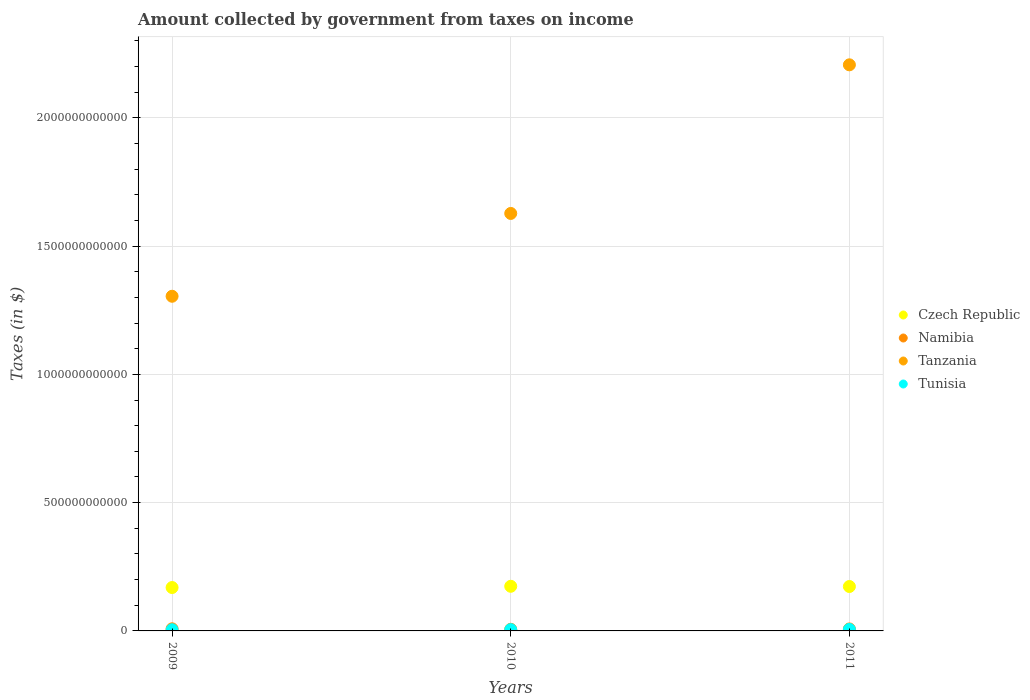What is the amount collected by government from taxes on income in Tunisia in 2010?
Offer a terse response. 5.03e+09. Across all years, what is the maximum amount collected by government from taxes on income in Tanzania?
Give a very brief answer. 2.21e+12. Across all years, what is the minimum amount collected by government from taxes on income in Tunisia?
Offer a very short reply. 4.65e+09. What is the total amount collected by government from taxes on income in Namibia in the graph?
Your answer should be very brief. 2.22e+1. What is the difference between the amount collected by government from taxes on income in Tanzania in 2009 and that in 2011?
Your answer should be compact. -9.02e+11. What is the difference between the amount collected by government from taxes on income in Tunisia in 2009 and the amount collected by government from taxes on income in Czech Republic in 2010?
Offer a terse response. -1.69e+11. What is the average amount collected by government from taxes on income in Czech Republic per year?
Ensure brevity in your answer.  1.72e+11. In the year 2010, what is the difference between the amount collected by government from taxes on income in Tanzania and amount collected by government from taxes on income in Tunisia?
Keep it short and to the point. 1.62e+12. In how many years, is the amount collected by government from taxes on income in Tanzania greater than 500000000000 $?
Your answer should be compact. 3. What is the ratio of the amount collected by government from taxes on income in Tanzania in 2010 to that in 2011?
Offer a terse response. 0.74. Is the amount collected by government from taxes on income in Tanzania in 2010 less than that in 2011?
Your answer should be compact. Yes. What is the difference between the highest and the second highest amount collected by government from taxes on income in Namibia?
Provide a succinct answer. 4.52e+08. What is the difference between the highest and the lowest amount collected by government from taxes on income in Tanzania?
Ensure brevity in your answer.  9.02e+11. In how many years, is the amount collected by government from taxes on income in Namibia greater than the average amount collected by government from taxes on income in Namibia taken over all years?
Your answer should be very brief. 2. Is the sum of the amount collected by government from taxes on income in Tanzania in 2009 and 2010 greater than the maximum amount collected by government from taxes on income in Namibia across all years?
Your response must be concise. Yes. Is it the case that in every year, the sum of the amount collected by government from taxes on income in Tanzania and amount collected by government from taxes on income in Namibia  is greater than the sum of amount collected by government from taxes on income in Czech Republic and amount collected by government from taxes on income in Tunisia?
Make the answer very short. Yes. Is it the case that in every year, the sum of the amount collected by government from taxes on income in Czech Republic and amount collected by government from taxes on income in Tanzania  is greater than the amount collected by government from taxes on income in Namibia?
Keep it short and to the point. Yes. How many years are there in the graph?
Provide a short and direct response. 3. What is the difference between two consecutive major ticks on the Y-axis?
Give a very brief answer. 5.00e+11. Are the values on the major ticks of Y-axis written in scientific E-notation?
Ensure brevity in your answer.  No. Does the graph contain any zero values?
Provide a succinct answer. No. Does the graph contain grids?
Offer a terse response. Yes. How many legend labels are there?
Make the answer very short. 4. How are the legend labels stacked?
Ensure brevity in your answer.  Vertical. What is the title of the graph?
Your answer should be compact. Amount collected by government from taxes on income. What is the label or title of the Y-axis?
Your response must be concise. Taxes (in $). What is the Taxes (in $) of Czech Republic in 2009?
Your answer should be very brief. 1.69e+11. What is the Taxes (in $) in Namibia in 2009?
Give a very brief answer. 8.14e+09. What is the Taxes (in $) of Tanzania in 2009?
Give a very brief answer. 1.30e+12. What is the Taxes (in $) in Tunisia in 2009?
Your answer should be very brief. 4.65e+09. What is the Taxes (in $) of Czech Republic in 2010?
Offer a very short reply. 1.74e+11. What is the Taxes (in $) of Namibia in 2010?
Provide a short and direct response. 6.33e+09. What is the Taxes (in $) of Tanzania in 2010?
Your answer should be very brief. 1.63e+12. What is the Taxes (in $) in Tunisia in 2010?
Your answer should be compact. 5.03e+09. What is the Taxes (in $) in Czech Republic in 2011?
Provide a succinct answer. 1.73e+11. What is the Taxes (in $) of Namibia in 2011?
Ensure brevity in your answer.  7.68e+09. What is the Taxes (in $) in Tanzania in 2011?
Offer a terse response. 2.21e+12. What is the Taxes (in $) in Tunisia in 2011?
Make the answer very short. 5.94e+09. Across all years, what is the maximum Taxes (in $) in Czech Republic?
Ensure brevity in your answer.  1.74e+11. Across all years, what is the maximum Taxes (in $) of Namibia?
Offer a terse response. 8.14e+09. Across all years, what is the maximum Taxes (in $) in Tanzania?
Keep it short and to the point. 2.21e+12. Across all years, what is the maximum Taxes (in $) in Tunisia?
Your response must be concise. 5.94e+09. Across all years, what is the minimum Taxes (in $) in Czech Republic?
Give a very brief answer. 1.69e+11. Across all years, what is the minimum Taxes (in $) in Namibia?
Your response must be concise. 6.33e+09. Across all years, what is the minimum Taxes (in $) in Tanzania?
Keep it short and to the point. 1.30e+12. Across all years, what is the minimum Taxes (in $) of Tunisia?
Give a very brief answer. 4.65e+09. What is the total Taxes (in $) of Czech Republic in the graph?
Provide a succinct answer. 5.16e+11. What is the total Taxes (in $) in Namibia in the graph?
Your answer should be very brief. 2.22e+1. What is the total Taxes (in $) in Tanzania in the graph?
Make the answer very short. 5.14e+12. What is the total Taxes (in $) of Tunisia in the graph?
Your response must be concise. 1.56e+1. What is the difference between the Taxes (in $) in Czech Republic in 2009 and that in 2010?
Offer a terse response. -4.83e+09. What is the difference between the Taxes (in $) in Namibia in 2009 and that in 2010?
Offer a terse response. 1.81e+09. What is the difference between the Taxes (in $) in Tanzania in 2009 and that in 2010?
Your answer should be compact. -3.23e+11. What is the difference between the Taxes (in $) of Tunisia in 2009 and that in 2010?
Provide a short and direct response. -3.87e+08. What is the difference between the Taxes (in $) in Czech Republic in 2009 and that in 2011?
Your response must be concise. -3.98e+09. What is the difference between the Taxes (in $) of Namibia in 2009 and that in 2011?
Ensure brevity in your answer.  4.52e+08. What is the difference between the Taxes (in $) of Tanzania in 2009 and that in 2011?
Give a very brief answer. -9.02e+11. What is the difference between the Taxes (in $) in Tunisia in 2009 and that in 2011?
Offer a very short reply. -1.29e+09. What is the difference between the Taxes (in $) of Czech Republic in 2010 and that in 2011?
Provide a succinct answer. 8.53e+08. What is the difference between the Taxes (in $) in Namibia in 2010 and that in 2011?
Give a very brief answer. -1.36e+09. What is the difference between the Taxes (in $) of Tanzania in 2010 and that in 2011?
Keep it short and to the point. -5.79e+11. What is the difference between the Taxes (in $) of Tunisia in 2010 and that in 2011?
Keep it short and to the point. -9.03e+08. What is the difference between the Taxes (in $) in Czech Republic in 2009 and the Taxes (in $) in Namibia in 2010?
Offer a very short reply. 1.63e+11. What is the difference between the Taxes (in $) in Czech Republic in 2009 and the Taxes (in $) in Tanzania in 2010?
Your response must be concise. -1.46e+12. What is the difference between the Taxes (in $) in Czech Republic in 2009 and the Taxes (in $) in Tunisia in 2010?
Your answer should be compact. 1.64e+11. What is the difference between the Taxes (in $) of Namibia in 2009 and the Taxes (in $) of Tanzania in 2010?
Offer a very short reply. -1.62e+12. What is the difference between the Taxes (in $) of Namibia in 2009 and the Taxes (in $) of Tunisia in 2010?
Your response must be concise. 3.10e+09. What is the difference between the Taxes (in $) of Tanzania in 2009 and the Taxes (in $) of Tunisia in 2010?
Give a very brief answer. 1.30e+12. What is the difference between the Taxes (in $) of Czech Republic in 2009 and the Taxes (in $) of Namibia in 2011?
Provide a succinct answer. 1.61e+11. What is the difference between the Taxes (in $) in Czech Republic in 2009 and the Taxes (in $) in Tanzania in 2011?
Keep it short and to the point. -2.04e+12. What is the difference between the Taxes (in $) in Czech Republic in 2009 and the Taxes (in $) in Tunisia in 2011?
Provide a short and direct response. 1.63e+11. What is the difference between the Taxes (in $) in Namibia in 2009 and the Taxes (in $) in Tanzania in 2011?
Your response must be concise. -2.20e+12. What is the difference between the Taxes (in $) of Namibia in 2009 and the Taxes (in $) of Tunisia in 2011?
Offer a terse response. 2.20e+09. What is the difference between the Taxes (in $) of Tanzania in 2009 and the Taxes (in $) of Tunisia in 2011?
Provide a succinct answer. 1.30e+12. What is the difference between the Taxes (in $) of Czech Republic in 2010 and the Taxes (in $) of Namibia in 2011?
Ensure brevity in your answer.  1.66e+11. What is the difference between the Taxes (in $) of Czech Republic in 2010 and the Taxes (in $) of Tanzania in 2011?
Give a very brief answer. -2.03e+12. What is the difference between the Taxes (in $) in Czech Republic in 2010 and the Taxes (in $) in Tunisia in 2011?
Give a very brief answer. 1.68e+11. What is the difference between the Taxes (in $) in Namibia in 2010 and the Taxes (in $) in Tanzania in 2011?
Give a very brief answer. -2.20e+12. What is the difference between the Taxes (in $) of Namibia in 2010 and the Taxes (in $) of Tunisia in 2011?
Your answer should be very brief. 3.93e+08. What is the difference between the Taxes (in $) of Tanzania in 2010 and the Taxes (in $) of Tunisia in 2011?
Provide a short and direct response. 1.62e+12. What is the average Taxes (in $) of Czech Republic per year?
Your answer should be very brief. 1.72e+11. What is the average Taxes (in $) of Namibia per year?
Your answer should be compact. 7.38e+09. What is the average Taxes (in $) in Tanzania per year?
Your answer should be compact. 1.71e+12. What is the average Taxes (in $) of Tunisia per year?
Ensure brevity in your answer.  5.20e+09. In the year 2009, what is the difference between the Taxes (in $) of Czech Republic and Taxes (in $) of Namibia?
Provide a succinct answer. 1.61e+11. In the year 2009, what is the difference between the Taxes (in $) in Czech Republic and Taxes (in $) in Tanzania?
Your response must be concise. -1.14e+12. In the year 2009, what is the difference between the Taxes (in $) in Czech Republic and Taxes (in $) in Tunisia?
Your answer should be very brief. 1.65e+11. In the year 2009, what is the difference between the Taxes (in $) of Namibia and Taxes (in $) of Tanzania?
Offer a terse response. -1.30e+12. In the year 2009, what is the difference between the Taxes (in $) in Namibia and Taxes (in $) in Tunisia?
Your answer should be compact. 3.49e+09. In the year 2009, what is the difference between the Taxes (in $) in Tanzania and Taxes (in $) in Tunisia?
Make the answer very short. 1.30e+12. In the year 2010, what is the difference between the Taxes (in $) of Czech Republic and Taxes (in $) of Namibia?
Provide a succinct answer. 1.68e+11. In the year 2010, what is the difference between the Taxes (in $) of Czech Republic and Taxes (in $) of Tanzania?
Your answer should be very brief. -1.45e+12. In the year 2010, what is the difference between the Taxes (in $) in Czech Republic and Taxes (in $) in Tunisia?
Provide a short and direct response. 1.69e+11. In the year 2010, what is the difference between the Taxes (in $) in Namibia and Taxes (in $) in Tanzania?
Make the answer very short. -1.62e+12. In the year 2010, what is the difference between the Taxes (in $) of Namibia and Taxes (in $) of Tunisia?
Keep it short and to the point. 1.30e+09. In the year 2010, what is the difference between the Taxes (in $) in Tanzania and Taxes (in $) in Tunisia?
Offer a terse response. 1.62e+12. In the year 2011, what is the difference between the Taxes (in $) of Czech Republic and Taxes (in $) of Namibia?
Your answer should be very brief. 1.65e+11. In the year 2011, what is the difference between the Taxes (in $) in Czech Republic and Taxes (in $) in Tanzania?
Offer a terse response. -2.03e+12. In the year 2011, what is the difference between the Taxes (in $) of Czech Republic and Taxes (in $) of Tunisia?
Your response must be concise. 1.67e+11. In the year 2011, what is the difference between the Taxes (in $) in Namibia and Taxes (in $) in Tanzania?
Provide a short and direct response. -2.20e+12. In the year 2011, what is the difference between the Taxes (in $) in Namibia and Taxes (in $) in Tunisia?
Provide a short and direct response. 1.75e+09. In the year 2011, what is the difference between the Taxes (in $) in Tanzania and Taxes (in $) in Tunisia?
Your answer should be very brief. 2.20e+12. What is the ratio of the Taxes (in $) of Czech Republic in 2009 to that in 2010?
Provide a short and direct response. 0.97. What is the ratio of the Taxes (in $) of Tanzania in 2009 to that in 2010?
Keep it short and to the point. 0.8. What is the ratio of the Taxes (in $) in Tunisia in 2009 to that in 2010?
Offer a very short reply. 0.92. What is the ratio of the Taxes (in $) of Namibia in 2009 to that in 2011?
Your response must be concise. 1.06. What is the ratio of the Taxes (in $) in Tanzania in 2009 to that in 2011?
Give a very brief answer. 0.59. What is the ratio of the Taxes (in $) of Tunisia in 2009 to that in 2011?
Give a very brief answer. 0.78. What is the ratio of the Taxes (in $) in Namibia in 2010 to that in 2011?
Provide a short and direct response. 0.82. What is the ratio of the Taxes (in $) of Tanzania in 2010 to that in 2011?
Provide a succinct answer. 0.74. What is the ratio of the Taxes (in $) in Tunisia in 2010 to that in 2011?
Offer a terse response. 0.85. What is the difference between the highest and the second highest Taxes (in $) in Czech Republic?
Your answer should be very brief. 8.53e+08. What is the difference between the highest and the second highest Taxes (in $) of Namibia?
Keep it short and to the point. 4.52e+08. What is the difference between the highest and the second highest Taxes (in $) in Tanzania?
Make the answer very short. 5.79e+11. What is the difference between the highest and the second highest Taxes (in $) in Tunisia?
Your answer should be compact. 9.03e+08. What is the difference between the highest and the lowest Taxes (in $) of Czech Republic?
Offer a very short reply. 4.83e+09. What is the difference between the highest and the lowest Taxes (in $) in Namibia?
Ensure brevity in your answer.  1.81e+09. What is the difference between the highest and the lowest Taxes (in $) of Tanzania?
Your answer should be very brief. 9.02e+11. What is the difference between the highest and the lowest Taxes (in $) of Tunisia?
Your response must be concise. 1.29e+09. 